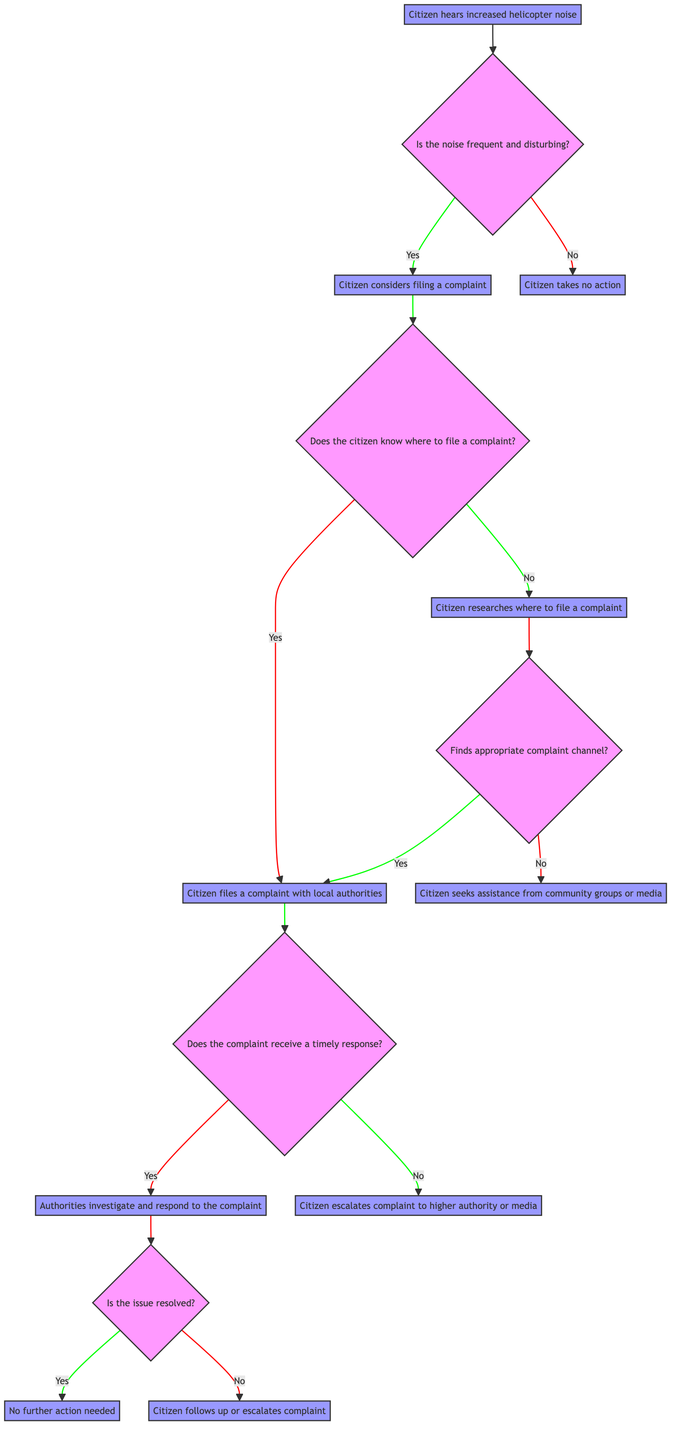What is the initial decision point in the diagram? The initial decision point is where the citizen hears increased helicopter noise, which is the starting action in the decision-making process.
Answer: Citizen hears increased helicopter noise How many main decision nodes are present in the diagram? The diagram has three main decision nodes: Is the noise frequent and disturbing?, Does the citizen know where to file a complaint?, and Does the complaint receive a timely response?
Answer: Three What action does a citizen take if the noise is not frequent and disturbing? The action taken by the citizen is to take no action, which is explicitly stated for this scenario in the diagram.
Answer: Citizen takes no action What happens if the citizen does not know where to file a complaint? If the citizen does not know where to file a complaint, they will research where to file a complaint according to the diagram's flow.
Answer: Citizen researches where to file a complaint If a citizen's complaint is not responded to in a timely manner, what action do they take? In case of a delayed response, the citizen escalates the complaint to a higher authority or media, as shown in the decision pathway.
Answer: Citizen escalates complaint to higher authority or media What is the outcome if the complaint receives a timely response and the issue is resolved? If the complaint receives a timely response and the issue is resolved, no further action is needed according to the flow in the diagram.
Answer: No further action needed If a citizen finds the appropriate complaint channel, what action do they take next? If the citizen finds the appropriate complaint channel, they proceed to file a complaint with local authorities, as per the decision structure presented.
Answer: Citizen files a complaint with local authorities What are the two possible outcomes after the investigation of the complaint? After the investigation, the two possible outcomes are that either the issue is resolved or it is not resolved, leading to different subsequent actions.
Answer: Issue resolved or not resolved 